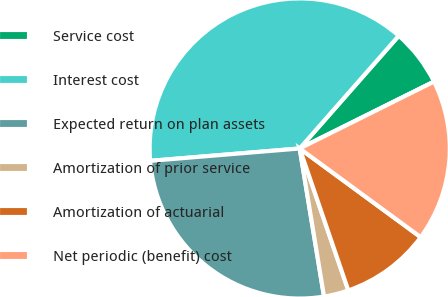<chart> <loc_0><loc_0><loc_500><loc_500><pie_chart><fcel>Service cost<fcel>Interest cost<fcel>Expected return on plan assets<fcel>Amortization of prior service<fcel>Amortization of actuarial<fcel>Net periodic (benefit) cost<nl><fcel>6.17%<fcel>37.79%<fcel>26.28%<fcel>2.66%<fcel>9.68%<fcel>17.42%<nl></chart> 